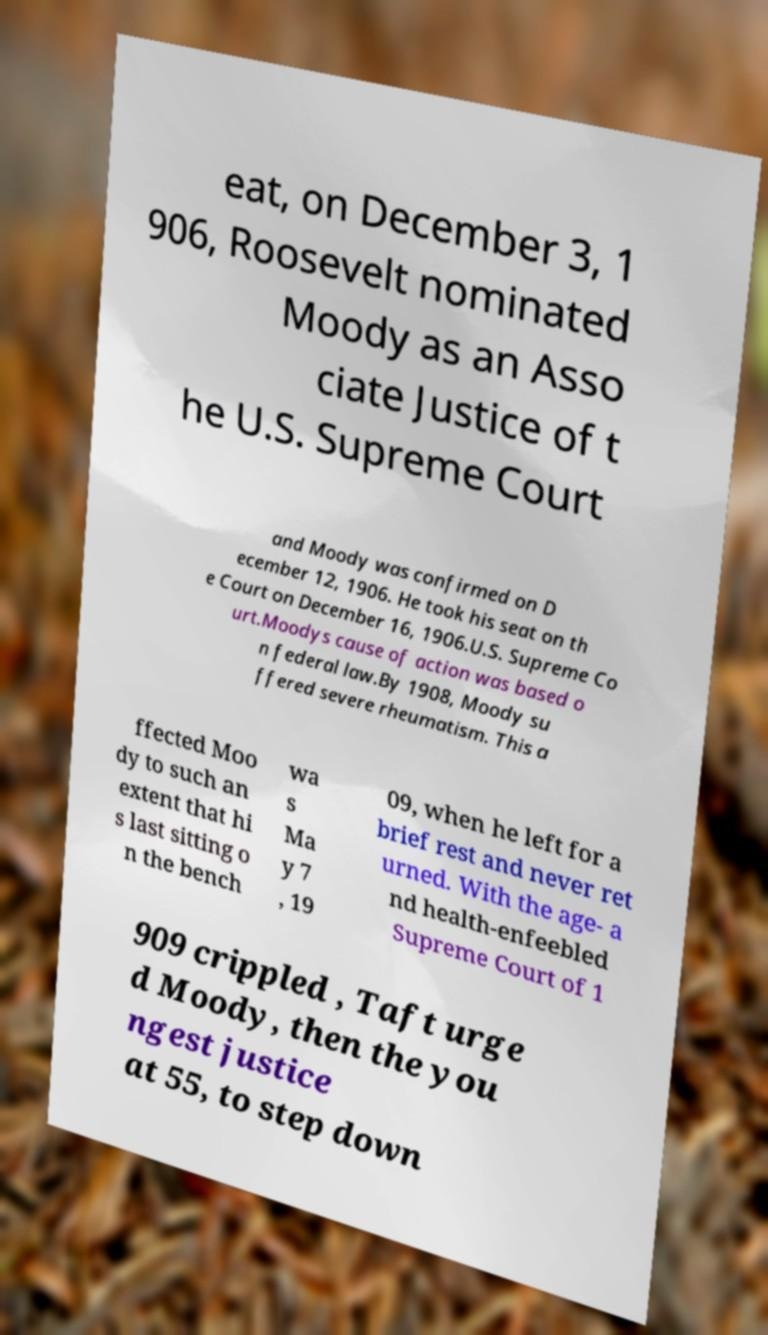Could you extract and type out the text from this image? eat, on December 3, 1 906, Roosevelt nominated Moody as an Asso ciate Justice of t he U.S. Supreme Court and Moody was confirmed on D ecember 12, 1906. He took his seat on th e Court on December 16, 1906.U.S. Supreme Co urt.Moodys cause of action was based o n federal law.By 1908, Moody su ffered severe rheumatism. This a ffected Moo dy to such an extent that hi s last sitting o n the bench wa s Ma y 7 , 19 09, when he left for a brief rest and never ret urned. With the age- a nd health-enfeebled Supreme Court of 1 909 crippled , Taft urge d Moody, then the you ngest justice at 55, to step down 